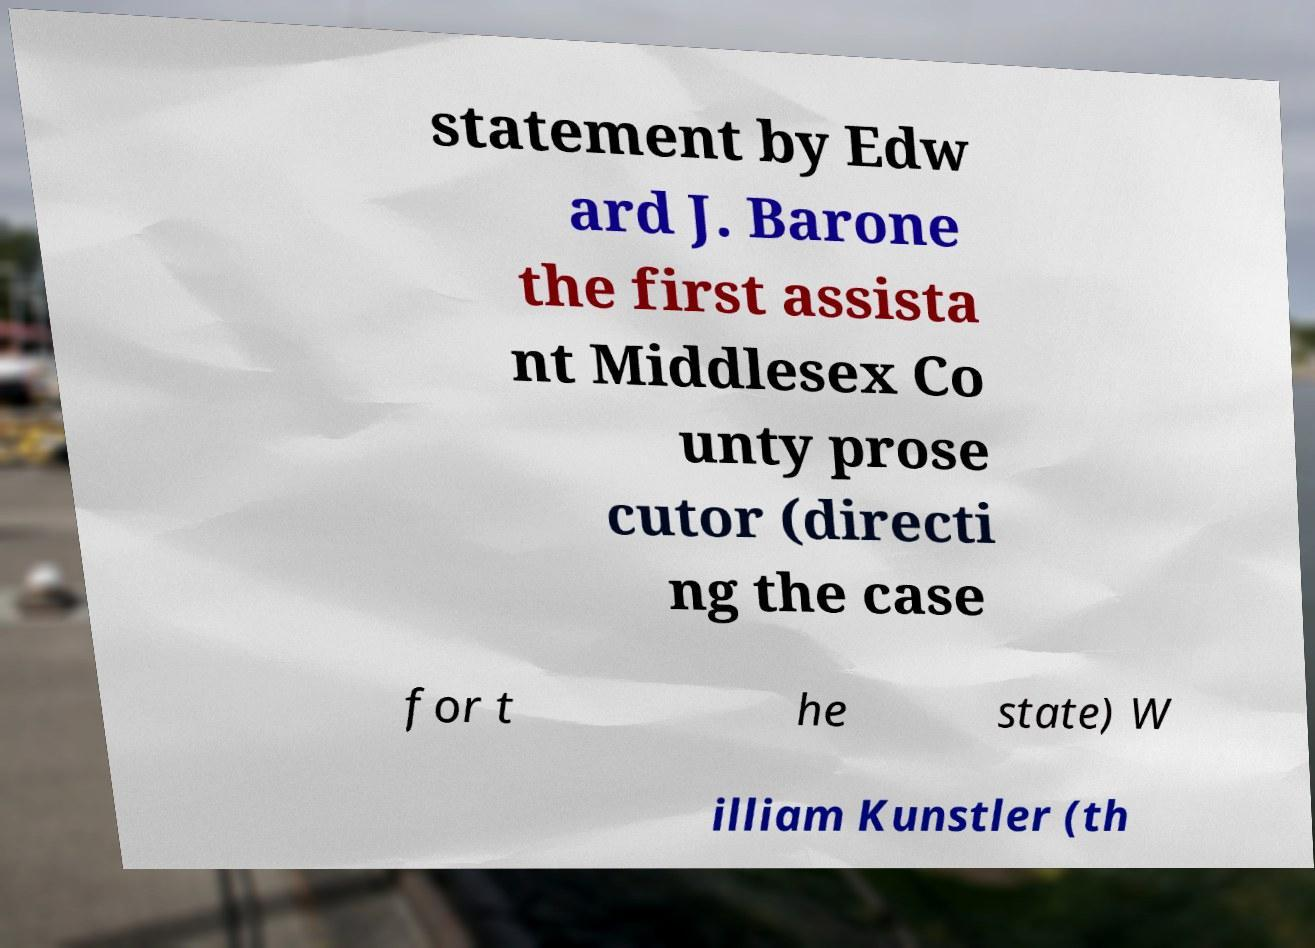There's text embedded in this image that I need extracted. Can you transcribe it verbatim? statement by Edw ard J. Barone the first assista nt Middlesex Co unty prose cutor (directi ng the case for t he state) W illiam Kunstler (th 